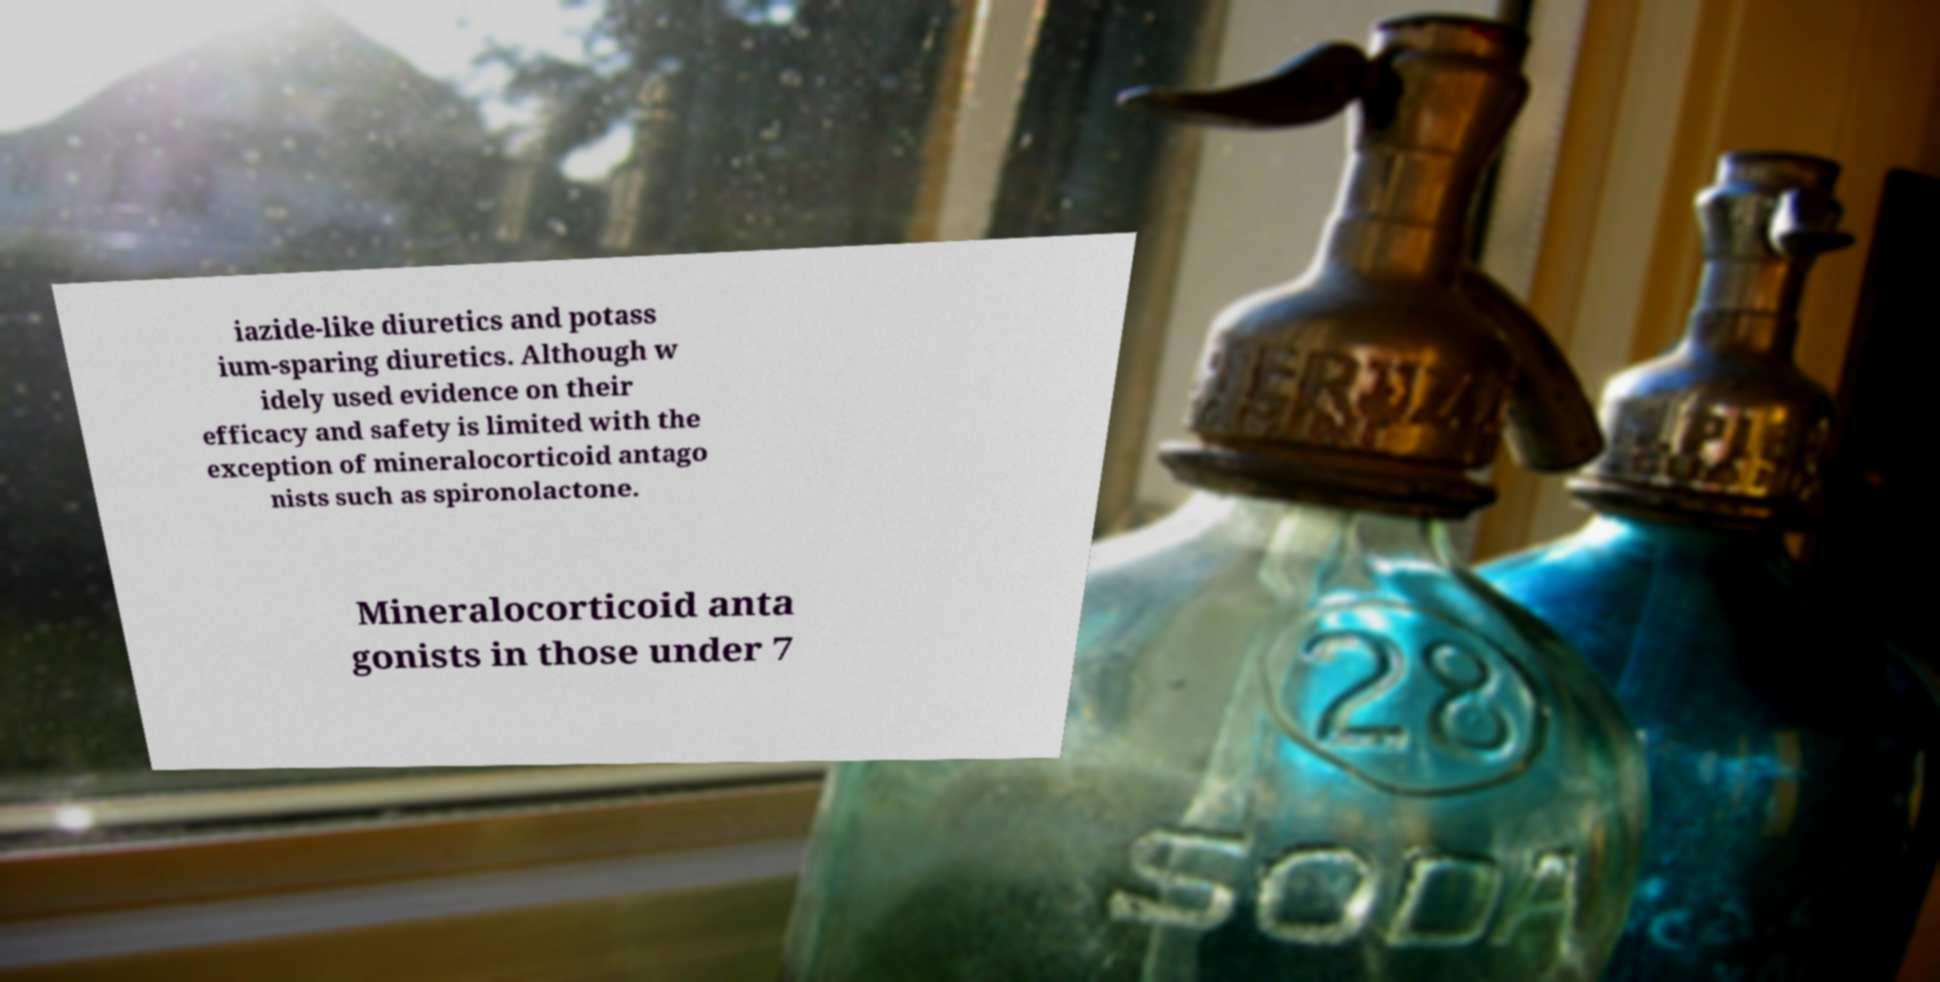Please identify and transcribe the text found in this image. iazide-like diuretics and potass ium-sparing diuretics. Although w idely used evidence on their efficacy and safety is limited with the exception of mineralocorticoid antago nists such as spironolactone. Mineralocorticoid anta gonists in those under 7 